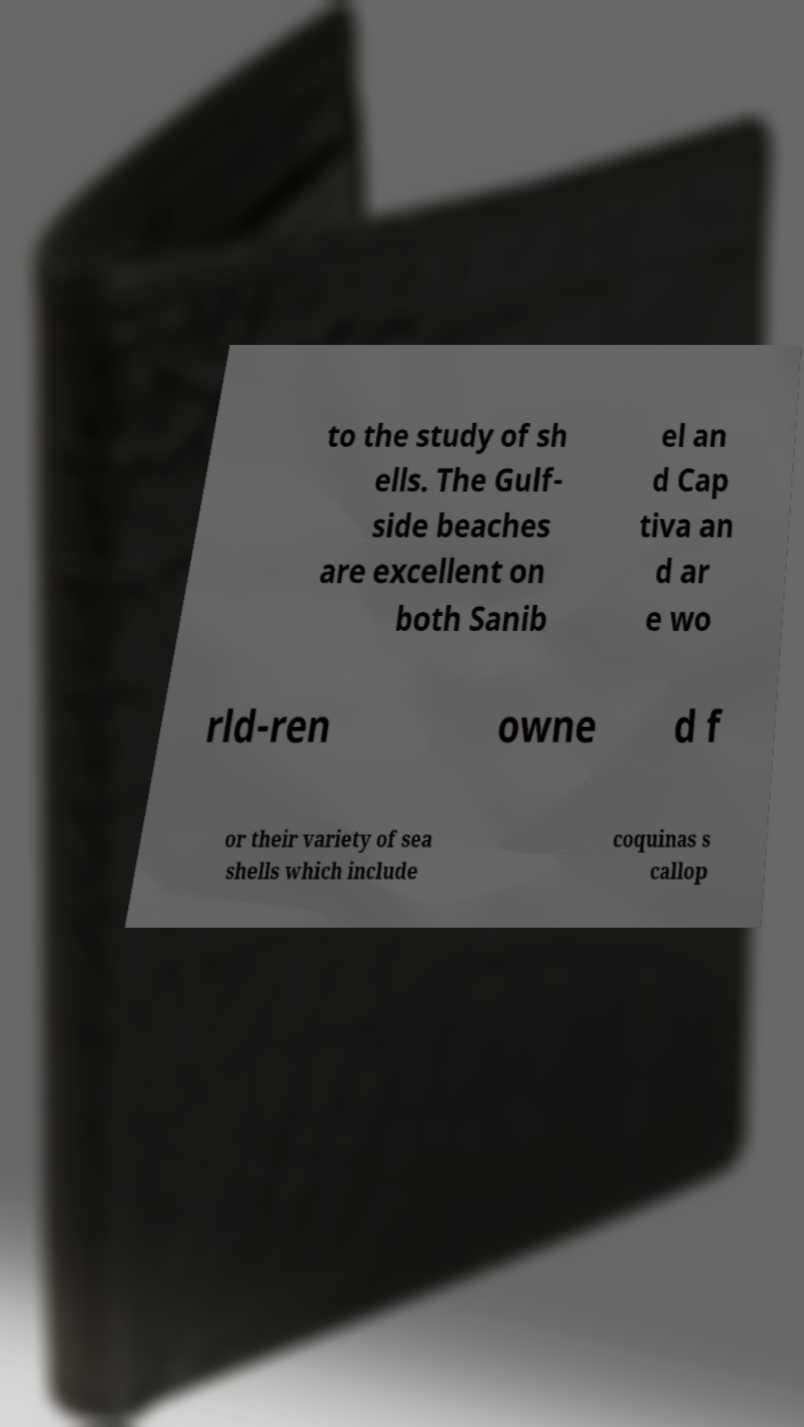Could you extract and type out the text from this image? to the study of sh ells. The Gulf- side beaches are excellent on both Sanib el an d Cap tiva an d ar e wo rld-ren owne d f or their variety of sea shells which include coquinas s callop 